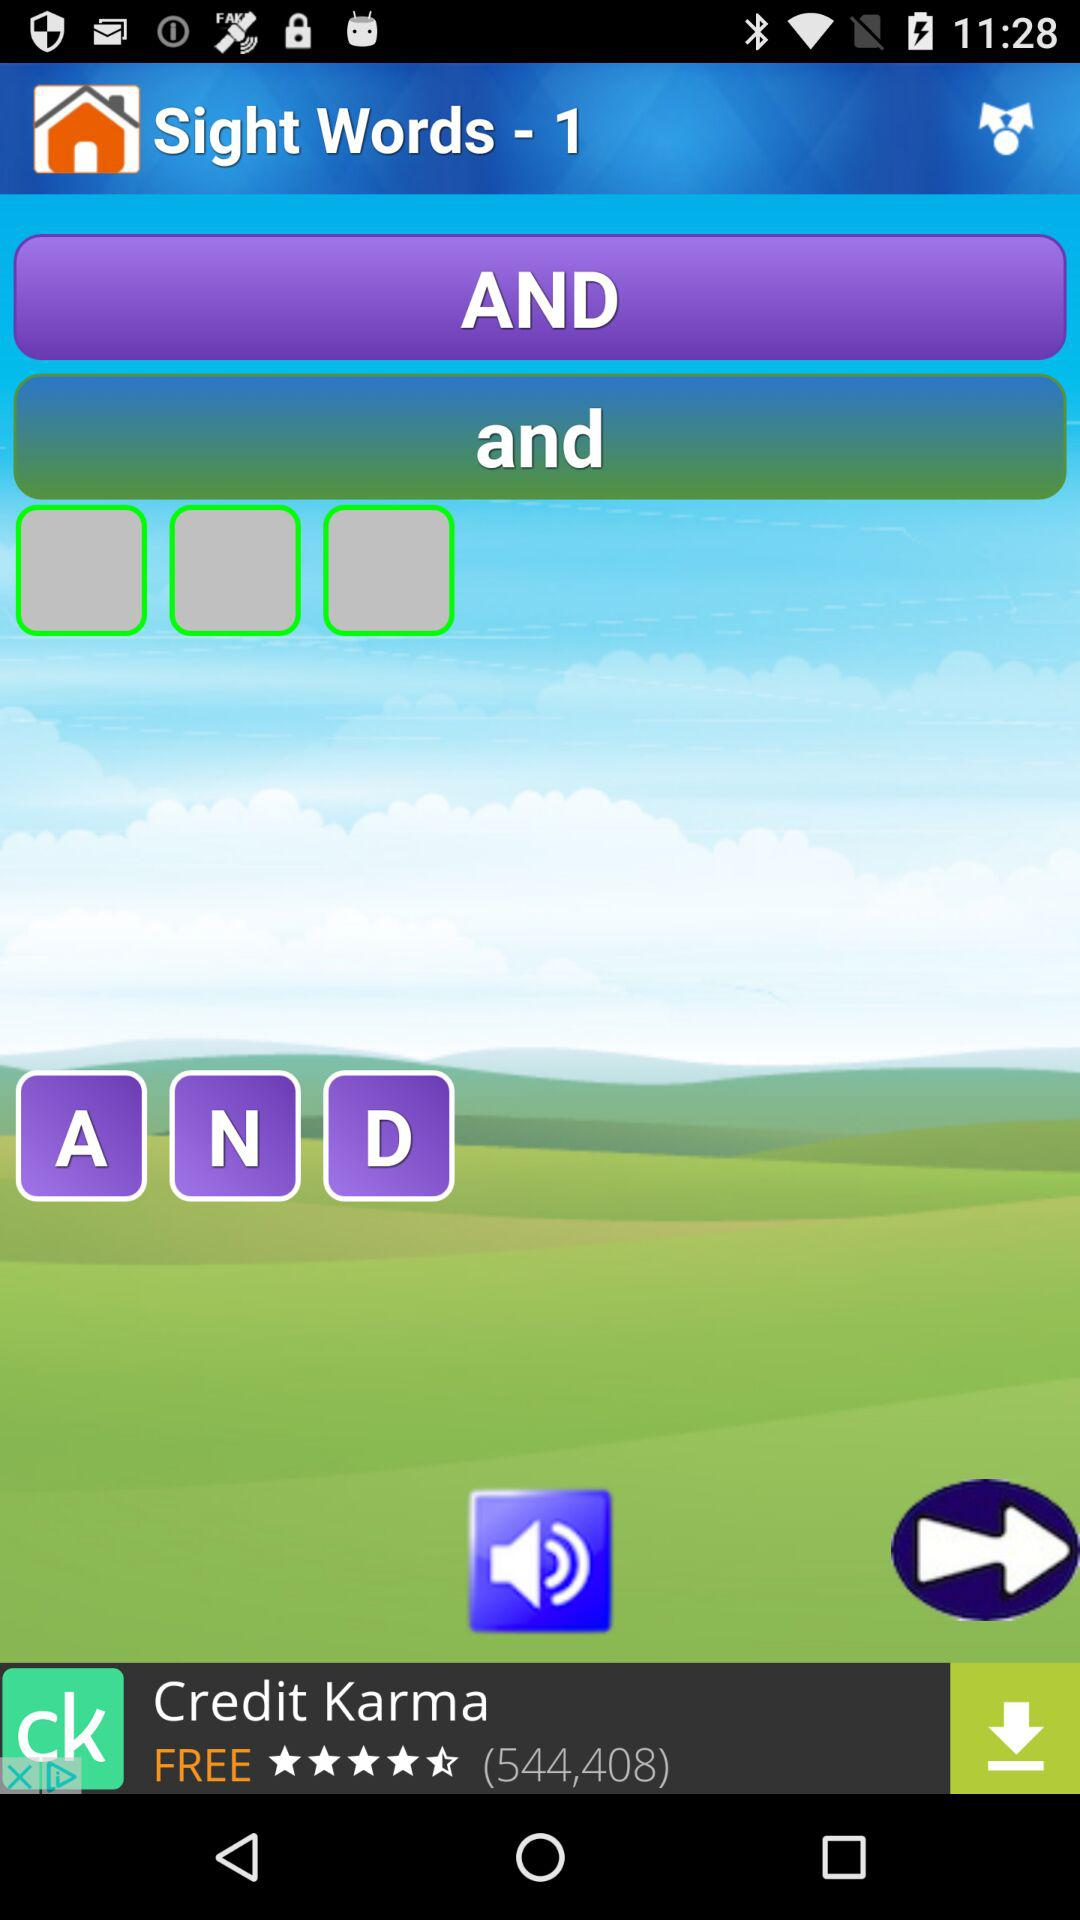What is the name of the application in the advertisement? The name of the application in the advertisement is "Credit Karma". 